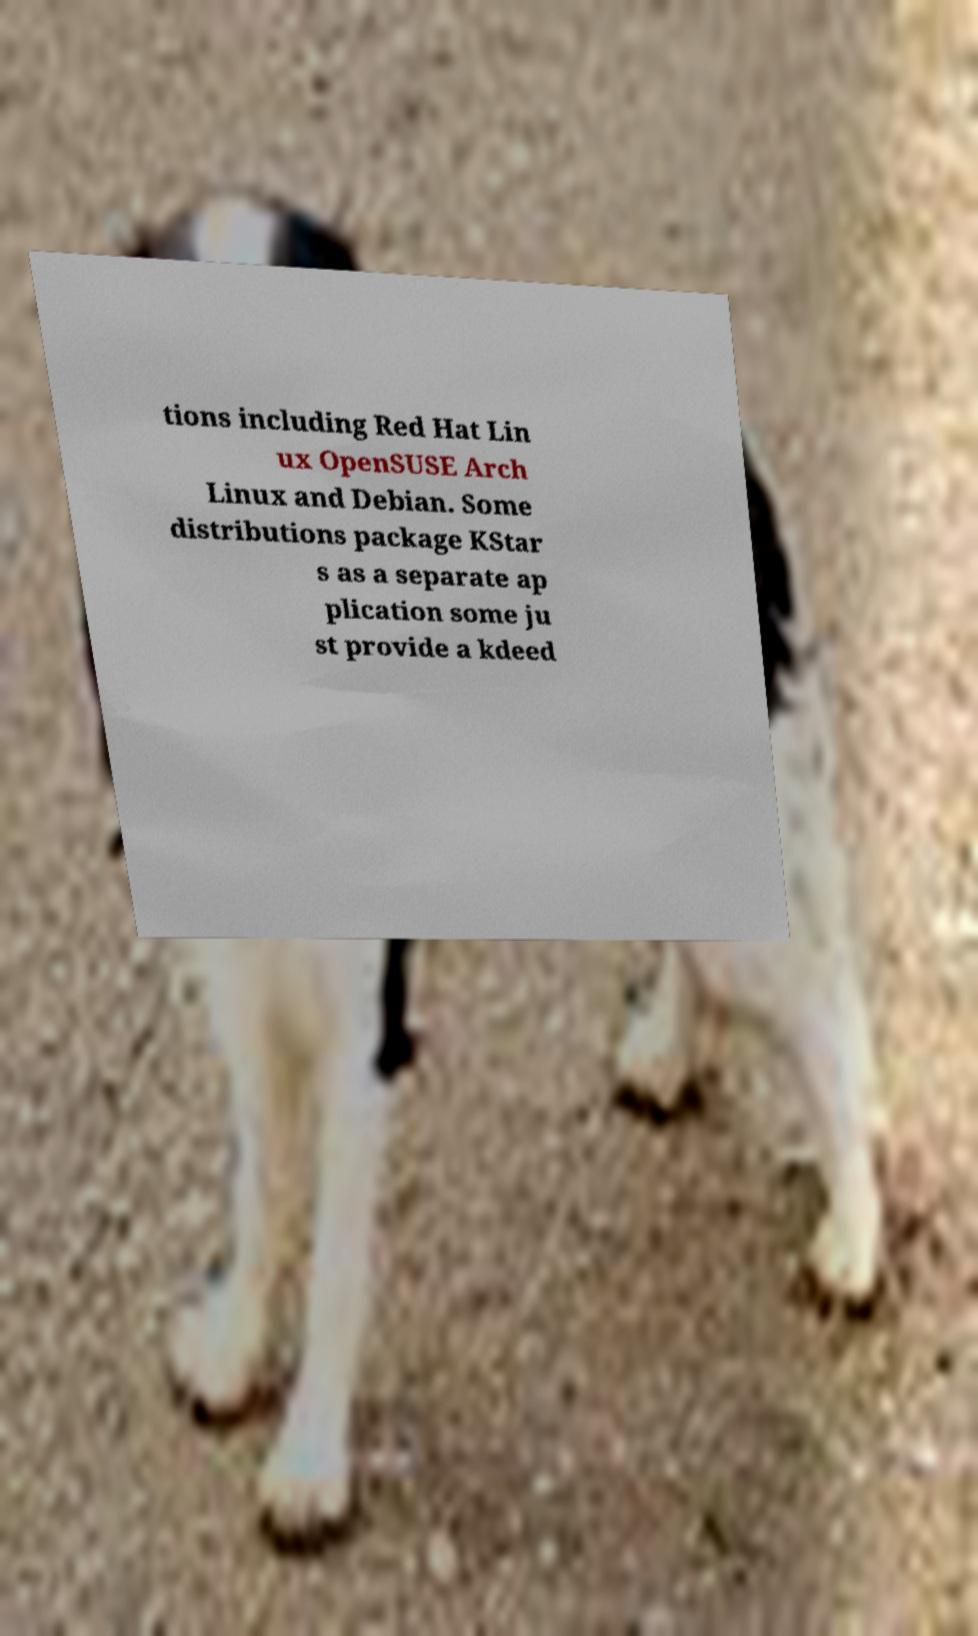I need the written content from this picture converted into text. Can you do that? tions including Red Hat Lin ux OpenSUSE Arch Linux and Debian. Some distributions package KStar s as a separate ap plication some ju st provide a kdeed 